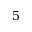<formula> <loc_0><loc_0><loc_500><loc_500>5</formula> 